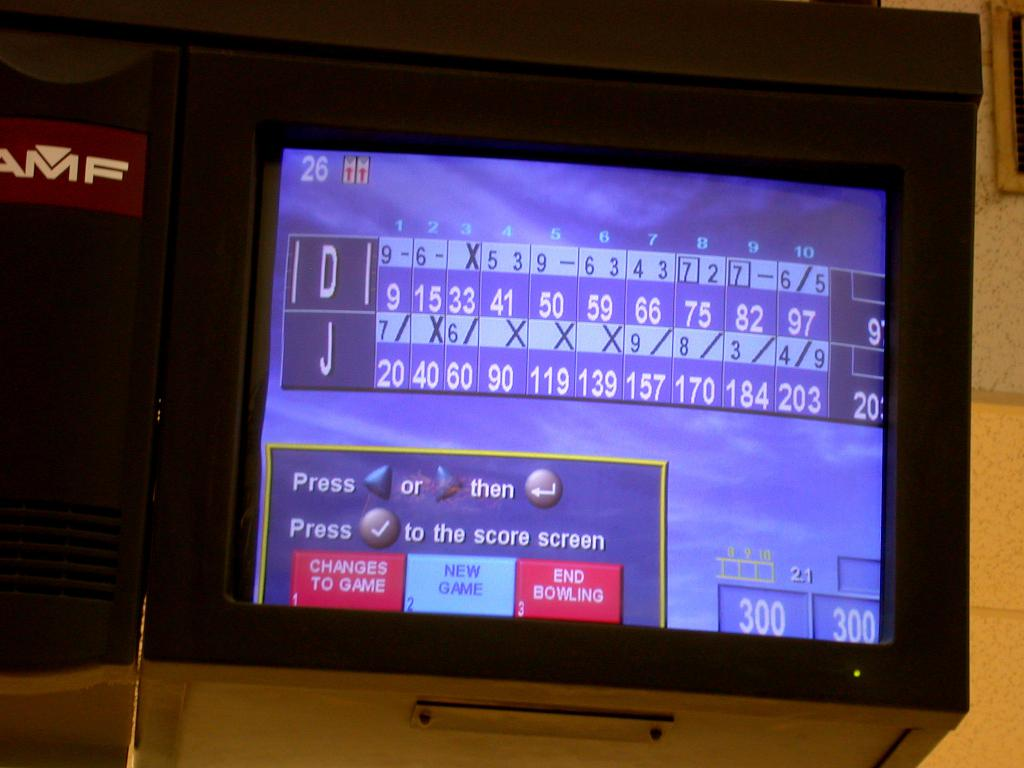Describe the scoring system shown in this bowling scoreboard. The scoreboard shows ten frames of bowling for each player, with scores that include strikes (X), spares (/), and individual pins knocked down. Players accumulate scores across frames, with special scoring like strikes and spares providing bonus points, culminating in a final total score. 